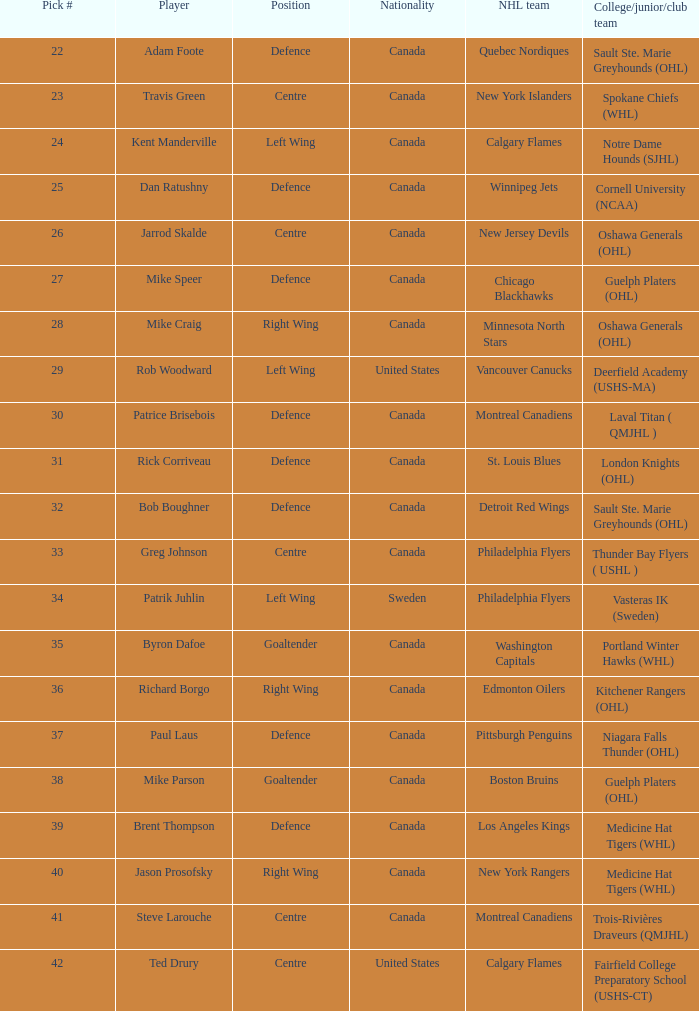How many draft picks is player byron dafoe? 1.0. 